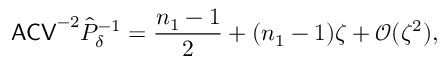Convert formula to latex. <formula><loc_0><loc_0><loc_500><loc_500>A C V ^ { - 2 } \hat { P } _ { \delta } ^ { - 1 } = \frac { n _ { 1 } - 1 } { 2 } + ( n _ { 1 } - 1 ) \zeta + \mathcal { O } ( \zeta ^ { 2 } ) ,</formula> 